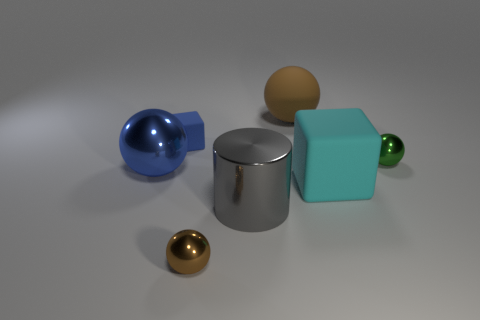Is there any other thing that has the same color as the big metal ball?
Your response must be concise. Yes. What number of metal objects have the same color as the rubber ball?
Ensure brevity in your answer.  1. What is the material of the large thing that is the same color as the small matte object?
Give a very brief answer. Metal. Is the color of the big shiny sphere the same as the matte block left of the big metallic cylinder?
Provide a short and direct response. Yes. Do the cube left of the big matte cube and the brown ball that is in front of the small green metallic thing have the same size?
Offer a terse response. Yes. What number of blocks are either small rubber objects or small green metallic objects?
Offer a terse response. 1. Is there a gray block?
Provide a succinct answer. No. Is there anything else that is the same shape as the gray shiny thing?
Offer a very short reply. No. Is the tiny matte cube the same color as the big metal sphere?
Offer a very short reply. Yes. What number of things are brown shiny balls in front of the green ball or blocks?
Your response must be concise. 3. 